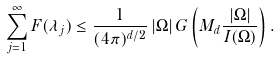Convert formula to latex. <formula><loc_0><loc_0><loc_500><loc_500>\sum _ { j = 1 } ^ { \infty } F ( \lambda _ { j } ) \leq \frac { 1 } { ( 4 \pi ) ^ { d / 2 } } \, | \Omega | \, G \left ( M _ { d } \frac { | \Omega | } { I ( \Omega ) } \right ) .</formula> 